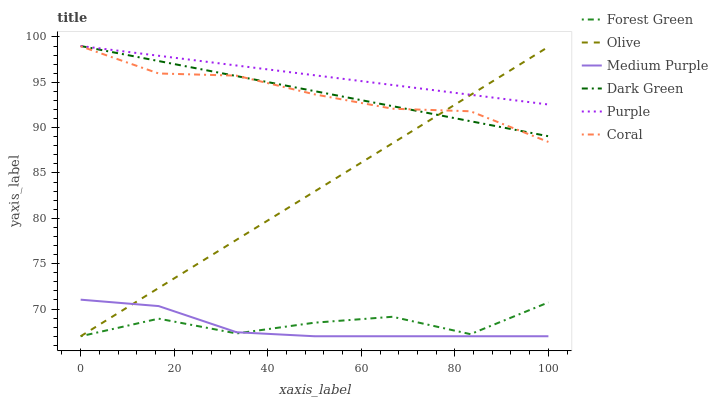Does Medium Purple have the minimum area under the curve?
Answer yes or no. Yes. Does Purple have the maximum area under the curve?
Answer yes or no. Yes. Does Coral have the minimum area under the curve?
Answer yes or no. No. Does Coral have the maximum area under the curve?
Answer yes or no. No. Is Purple the smoothest?
Answer yes or no. Yes. Is Forest Green the roughest?
Answer yes or no. Yes. Is Coral the smoothest?
Answer yes or no. No. Is Coral the roughest?
Answer yes or no. No. Does Coral have the lowest value?
Answer yes or no. No. Does Coral have the highest value?
Answer yes or no. No. Is Forest Green less than Coral?
Answer yes or no. Yes. Is Coral greater than Medium Purple?
Answer yes or no. Yes. Does Forest Green intersect Coral?
Answer yes or no. No. 